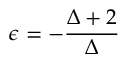<formula> <loc_0><loc_0><loc_500><loc_500>\epsilon = - \frac { \Delta + 2 } { \Delta }</formula> 